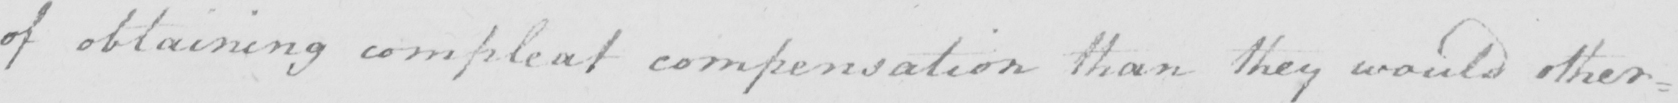Can you read and transcribe this handwriting? of obtaining compleat compensation than they would other= 